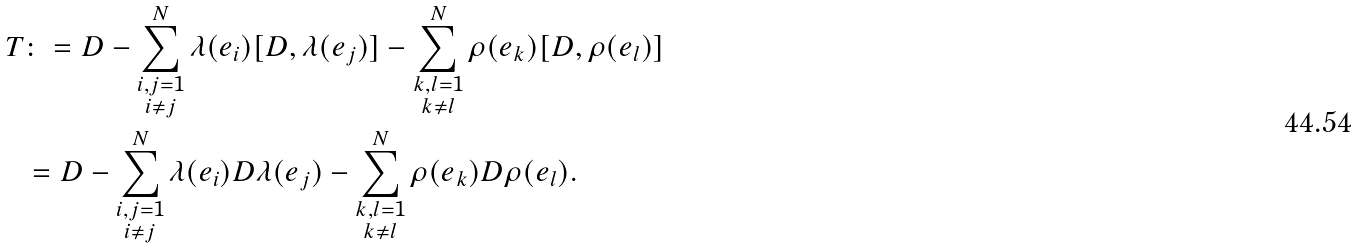Convert formula to latex. <formula><loc_0><loc_0><loc_500><loc_500>T & \colon = D - \sum _ { \substack { i , j = 1 \\ i \neq j } } ^ { N } \lambda ( e _ { i } ) [ D , \lambda ( e _ { j } ) ] - \sum _ { \substack { k , l = 1 \\ k \neq l } } ^ { N } \rho ( e _ { k } ) [ D , \rho ( e _ { l } ) ] \\ & = D - \sum _ { \substack { i , j = 1 \\ i \neq j } } ^ { N } \lambda ( e _ { i } ) D \lambda ( e _ { j } ) - \sum _ { \substack { k , l = 1 \\ k \neq l } } ^ { N } \rho ( e _ { k } ) D \rho ( e _ { l } ) .</formula> 